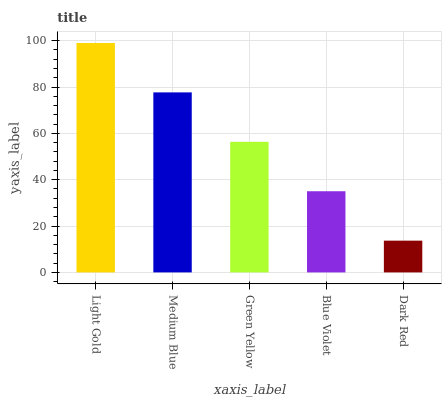Is Medium Blue the minimum?
Answer yes or no. No. Is Medium Blue the maximum?
Answer yes or no. No. Is Light Gold greater than Medium Blue?
Answer yes or no. Yes. Is Medium Blue less than Light Gold?
Answer yes or no. Yes. Is Medium Blue greater than Light Gold?
Answer yes or no. No. Is Light Gold less than Medium Blue?
Answer yes or no. No. Is Green Yellow the high median?
Answer yes or no. Yes. Is Green Yellow the low median?
Answer yes or no. Yes. Is Dark Red the high median?
Answer yes or no. No. Is Light Gold the low median?
Answer yes or no. No. 